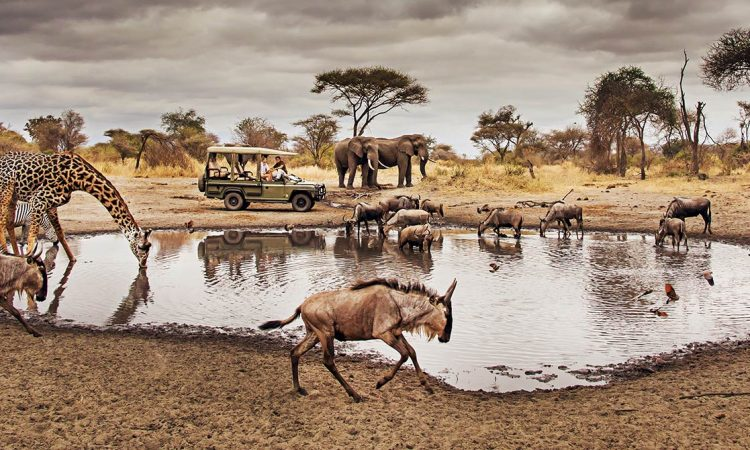Describe a plausible day in the life of an elephant in this scene. Early morning, as the sun rises over the Serengeti, the elephants begin their day by quenching their thirst at the watering hole. They travel in a close-knit herd, with the matriarch leading the way. After drinking, they move towards areas with lush vegetation to forage. Using their dexterous trunks, they strip leaves, branches, and bark from trees. By midday, they rest under the shade of acacia trees to escape the scorching sun. In the afternoon, they might playfully interact, bathing in mud to protect their skin from pests. As evening approaches, they return to the watering hole for another drink before finding a safe place to rest for the night. Can you succinctly describe an interesting fact about giraffes? Giraffes have a unique cardiovascular system that includes a powerful heart and specialized blood vessels to manage the high blood pressure needed to pump blood all the way to their brains. 